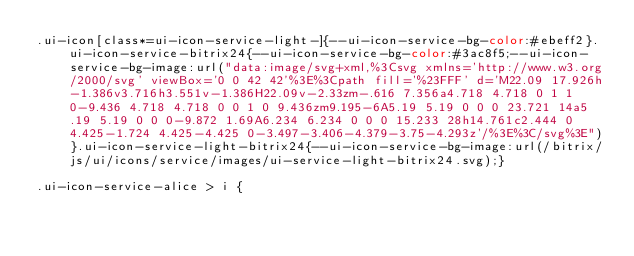<code> <loc_0><loc_0><loc_500><loc_500><_CSS_>.ui-icon[class*=ui-icon-service-light-]{--ui-icon-service-bg-color:#ebeff2}.ui-icon-service-bitrix24{--ui-icon-service-bg-color:#3ac8f5;--ui-icon-service-bg-image:url("data:image/svg+xml,%3Csvg xmlns='http://www.w3.org/2000/svg' viewBox='0 0 42 42'%3E%3Cpath fill='%23FFF' d='M22.09 17.926h-1.386v3.716h3.551v-1.386H22.09v-2.33zm-.616 7.356a4.718 4.718 0 1 1 0-9.436 4.718 4.718 0 0 1 0 9.436zm9.195-6A5.19 5.19 0 0 0 23.721 14a5.19 5.19 0 0 0-9.872 1.69A6.234 6.234 0 0 0 15.233 28h14.761c2.444 0 4.425-1.724 4.425-4.425 0-3.497-3.406-4.379-3.75-4.293z'/%3E%3C/svg%3E")}.ui-icon-service-light-bitrix24{--ui-icon-service-bg-image:url(/bitrix/js/ui/icons/service/images/ui-service-light-bitrix24.svg);}

.ui-icon-service-alice > i {</code> 